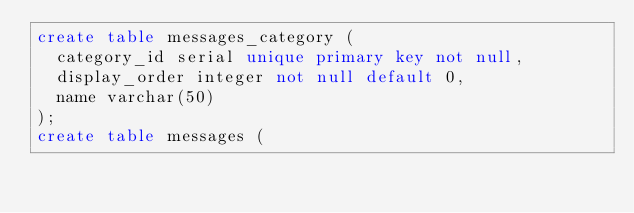Convert code to text. <code><loc_0><loc_0><loc_500><loc_500><_SQL_>create table messages_category (
  category_id serial unique primary key not null,
  display_order integer not null default 0,
  name varchar(50)
);
create table messages (</code> 